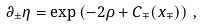<formula> <loc_0><loc_0><loc_500><loc_500>\partial _ { \pm } \eta = \exp \left ( - 2 \rho + C _ { \mp } ( x _ { \mp } ) \right ) \, ,</formula> 